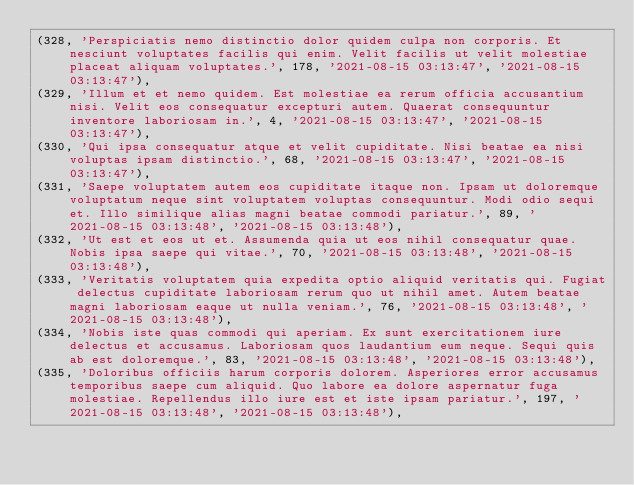Convert code to text. <code><loc_0><loc_0><loc_500><loc_500><_SQL_>(328, 'Perspiciatis nemo distinctio dolor quidem culpa non corporis. Et nesciunt voluptates facilis qui enim. Velit facilis ut velit molestiae placeat aliquam voluptates.', 178, '2021-08-15 03:13:47', '2021-08-15 03:13:47'),
(329, 'Illum et et nemo quidem. Est molestiae ea rerum officia accusantium nisi. Velit eos consequatur excepturi autem. Quaerat consequuntur inventore laboriosam in.', 4, '2021-08-15 03:13:47', '2021-08-15 03:13:47'),
(330, 'Qui ipsa consequatur atque et velit cupiditate. Nisi beatae ea nisi voluptas ipsam distinctio.', 68, '2021-08-15 03:13:47', '2021-08-15 03:13:47'),
(331, 'Saepe voluptatem autem eos cupiditate itaque non. Ipsam ut doloremque voluptatum neque sint voluptatem voluptas consequuntur. Modi odio sequi et. Illo similique alias magni beatae commodi pariatur.', 89, '2021-08-15 03:13:48', '2021-08-15 03:13:48'),
(332, 'Ut est et eos ut et. Assumenda quia ut eos nihil consequatur quae. Nobis ipsa saepe qui vitae.', 70, '2021-08-15 03:13:48', '2021-08-15 03:13:48'),
(333, 'Veritatis voluptatem quia expedita optio aliquid veritatis qui. Fugiat delectus cupiditate laboriosam rerum quo ut nihil amet. Autem beatae magni laboriosam eaque ut nulla veniam.', 76, '2021-08-15 03:13:48', '2021-08-15 03:13:48'),
(334, 'Nobis iste quas commodi qui aperiam. Ex sunt exercitationem iure delectus et accusamus. Laboriosam quos laudantium eum neque. Sequi quis ab est doloremque.', 83, '2021-08-15 03:13:48', '2021-08-15 03:13:48'),
(335, 'Doloribus officiis harum corporis dolorem. Asperiores error accusamus temporibus saepe cum aliquid. Quo labore ea dolore aspernatur fuga molestiae. Repellendus illo iure est et iste ipsam pariatur.', 197, '2021-08-15 03:13:48', '2021-08-15 03:13:48'),</code> 